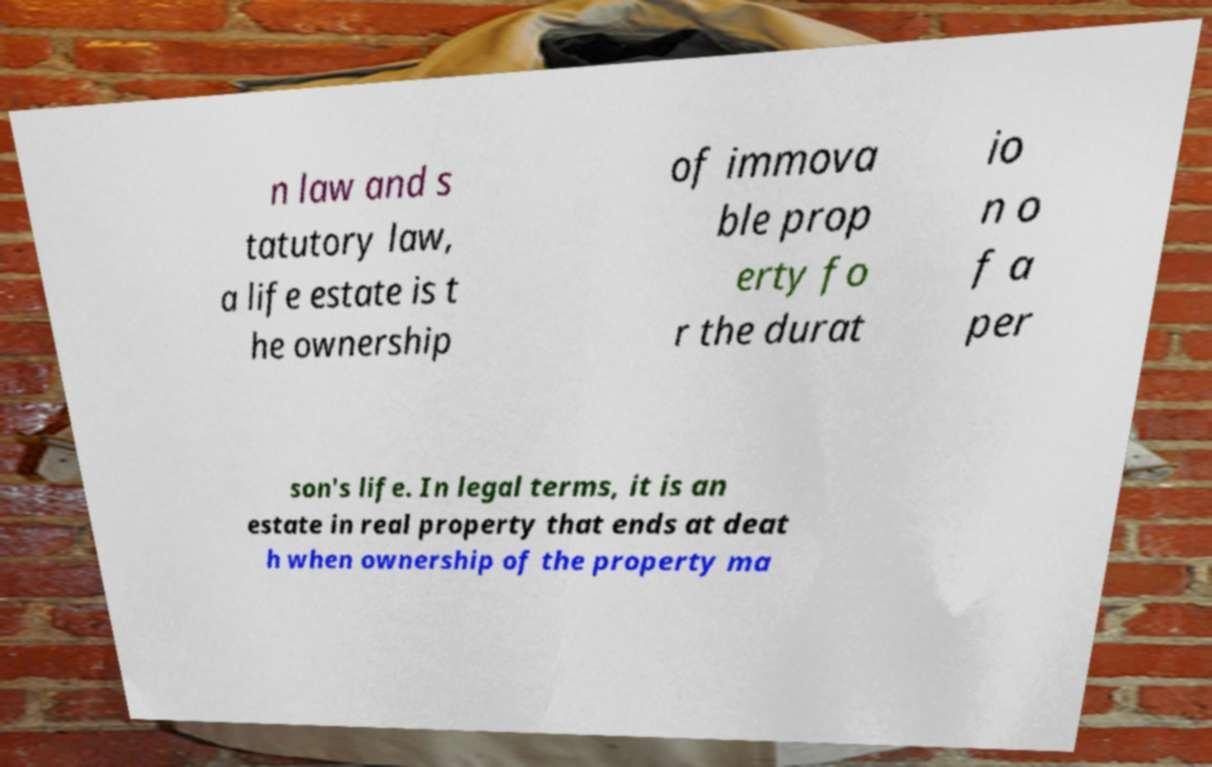Please read and relay the text visible in this image. What does it say? n law and s tatutory law, a life estate is t he ownership of immova ble prop erty fo r the durat io n o f a per son's life. In legal terms, it is an estate in real property that ends at deat h when ownership of the property ma 